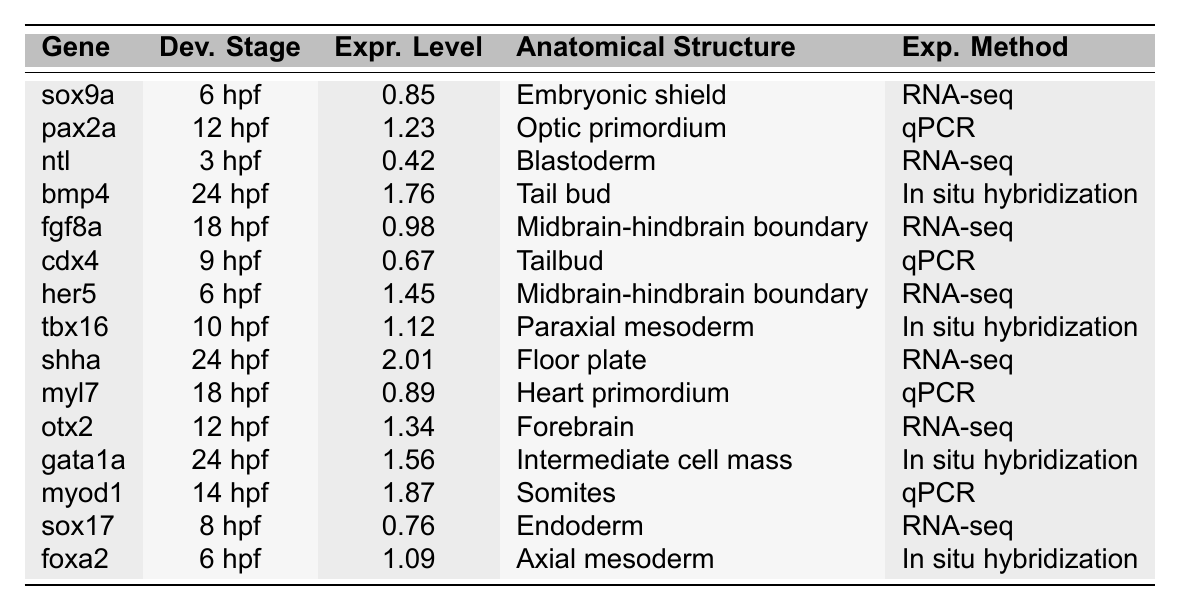What is the expression level of the gene sox9a at 6 hpf? The table shows that the expression level of sox9a at the developmental stage of 6 hpf is 0.85.
Answer: 0.85 Which anatomical structure is associated with the gene pax2a at 12 hpf? According to the table, pax2a is associated with the optic primordium at 12 hpf.
Answer: Optic primordium What is the highest expression level reported in the table? The highest expression level listed in the table is 2.01 for the gene shha at 24 hpf.
Answer: 2.01 At what developmental stage does the gene ntl show its expression? The gene ntl is expressed at the developmental stage of 3 hpf according to the table.
Answer: 3 hpf Which gene has the lowest expression level, and what is that level? The gene ntl has the lowest expression level in the table, which is 0.42.
Answer: ntl, 0.42 What is the average expression level of genes recorded at 24 hpf? The expression levels of genes at 24 hpf are: bmp4 (1.76), shha (2.01), and gata1a (1.56). The average is (1.76 + 2.01 + 1.56) / 3 = 1.7767, which rounds to 1.78.
Answer: 1.78 Is the expression level of the gene myod1 at 14 hpf higher than the expression level of the gene cdx4 at 9 hpf? The expression level of myod1 at 14 hpf is 1.87 and the expression level of cdx4 at 9 hpf is 0.67. Since 1.87 is greater than 0.67, the statement is true.
Answer: Yes How many genes are expressed at 6 hpf, and what are their names? The table lists two genes expressed at 6 hpf: sox9a and her5.
Answer: 2 genes: sox9a, her5 What gene is expressed in the midbrain-hindbrain boundary at 18 hpf? The table indicates that fgf8a is expressed in the midbrain-hindbrain boundary at 18 hpf.
Answer: fgf8a At which developmental stage and anatomical structure is the gene foxa2 expressed? The gene foxa2 is expressed at 6 hpf in the axial mesoderm according to the table.
Answer: 6 hpf, Axial mesoderm 